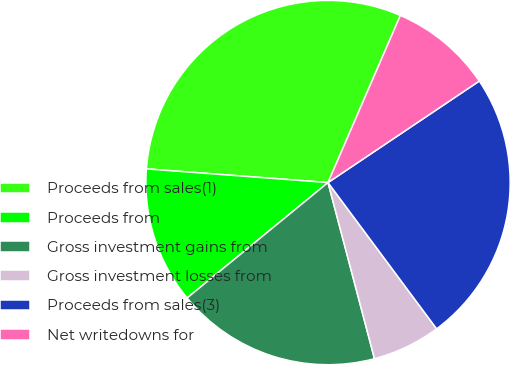Convert chart. <chart><loc_0><loc_0><loc_500><loc_500><pie_chart><fcel>Proceeds from sales(1)<fcel>Proceeds from<fcel>Gross investment gains from<fcel>Gross investment losses from<fcel>Proceeds from sales(3)<fcel>Net writedowns for<nl><fcel>30.3%<fcel>12.12%<fcel>18.18%<fcel>6.06%<fcel>24.24%<fcel>9.09%<nl></chart> 